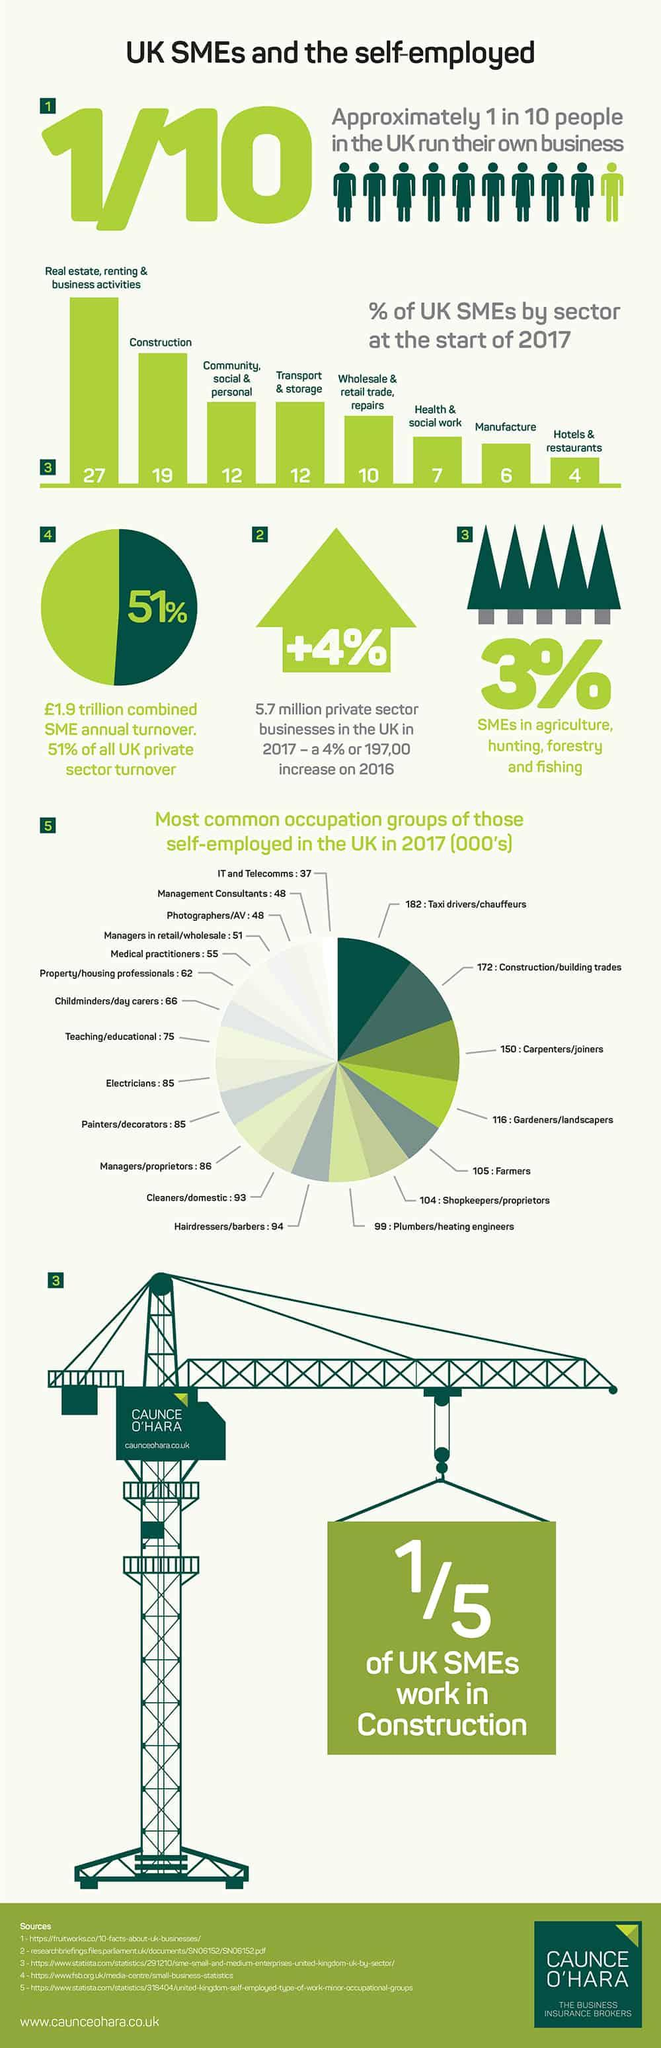Outline some significant characteristics in this image. The occupation group with the highest share is taxi drivers/chauffeurs. Approximately 25% of the total value of U.S. exports to Canada in 2020 was accounted for by construction and manufacturing industries combined. The infographic contains five tree icons. The total number of painters and joiners taken together is 235. The total of farmers and electricians taken together is 190. 